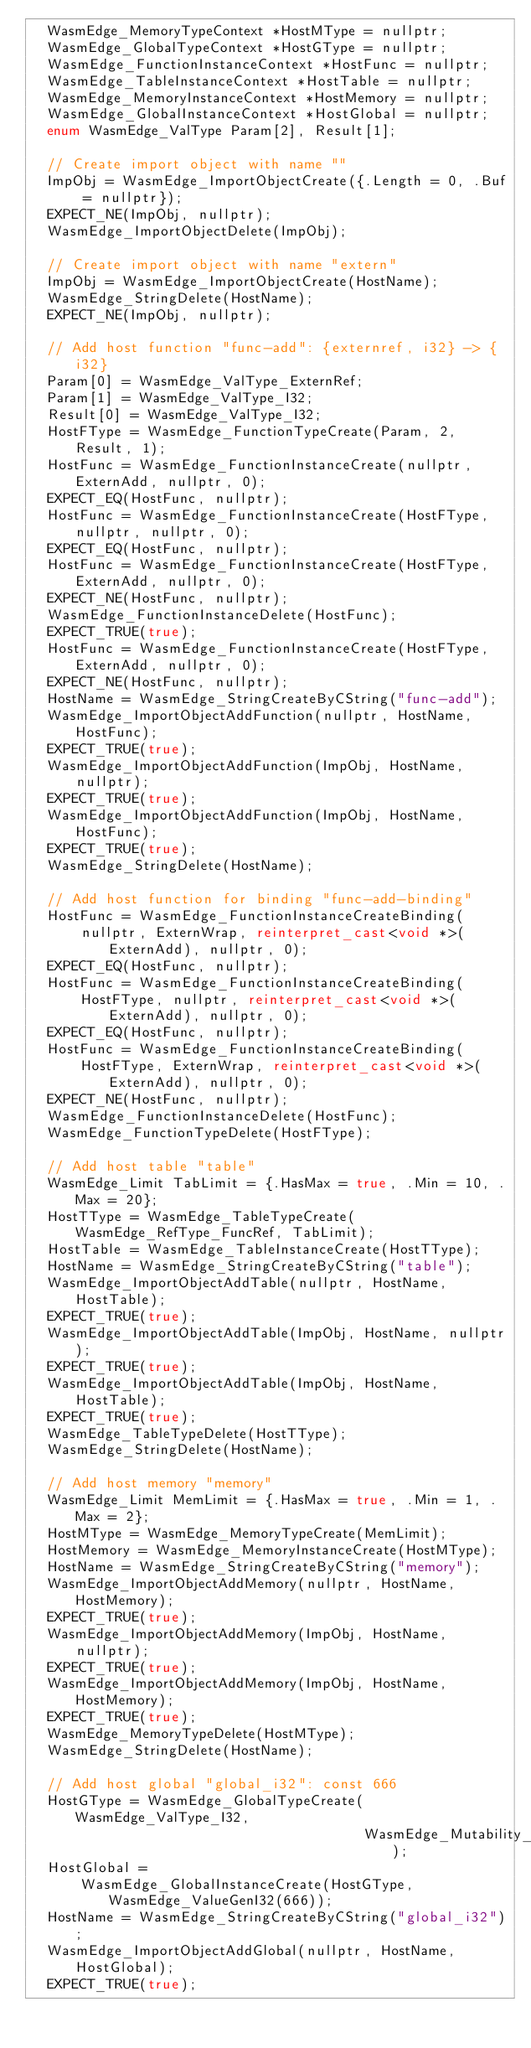Convert code to text. <code><loc_0><loc_0><loc_500><loc_500><_C++_>  WasmEdge_MemoryTypeContext *HostMType = nullptr;
  WasmEdge_GlobalTypeContext *HostGType = nullptr;
  WasmEdge_FunctionInstanceContext *HostFunc = nullptr;
  WasmEdge_TableInstanceContext *HostTable = nullptr;
  WasmEdge_MemoryInstanceContext *HostMemory = nullptr;
  WasmEdge_GlobalInstanceContext *HostGlobal = nullptr;
  enum WasmEdge_ValType Param[2], Result[1];

  // Create import object with name ""
  ImpObj = WasmEdge_ImportObjectCreate({.Length = 0, .Buf = nullptr});
  EXPECT_NE(ImpObj, nullptr);
  WasmEdge_ImportObjectDelete(ImpObj);

  // Create import object with name "extern"
  ImpObj = WasmEdge_ImportObjectCreate(HostName);
  WasmEdge_StringDelete(HostName);
  EXPECT_NE(ImpObj, nullptr);

  // Add host function "func-add": {externref, i32} -> {i32}
  Param[0] = WasmEdge_ValType_ExternRef;
  Param[1] = WasmEdge_ValType_I32;
  Result[0] = WasmEdge_ValType_I32;
  HostFType = WasmEdge_FunctionTypeCreate(Param, 2, Result, 1);
  HostFunc = WasmEdge_FunctionInstanceCreate(nullptr, ExternAdd, nullptr, 0);
  EXPECT_EQ(HostFunc, nullptr);
  HostFunc = WasmEdge_FunctionInstanceCreate(HostFType, nullptr, nullptr, 0);
  EXPECT_EQ(HostFunc, nullptr);
  HostFunc = WasmEdge_FunctionInstanceCreate(HostFType, ExternAdd, nullptr, 0);
  EXPECT_NE(HostFunc, nullptr);
  WasmEdge_FunctionInstanceDelete(HostFunc);
  EXPECT_TRUE(true);
  HostFunc = WasmEdge_FunctionInstanceCreate(HostFType, ExternAdd, nullptr, 0);
  EXPECT_NE(HostFunc, nullptr);
  HostName = WasmEdge_StringCreateByCString("func-add");
  WasmEdge_ImportObjectAddFunction(nullptr, HostName, HostFunc);
  EXPECT_TRUE(true);
  WasmEdge_ImportObjectAddFunction(ImpObj, HostName, nullptr);
  EXPECT_TRUE(true);
  WasmEdge_ImportObjectAddFunction(ImpObj, HostName, HostFunc);
  EXPECT_TRUE(true);
  WasmEdge_StringDelete(HostName);

  // Add host function for binding "func-add-binding"
  HostFunc = WasmEdge_FunctionInstanceCreateBinding(
      nullptr, ExternWrap, reinterpret_cast<void *>(ExternAdd), nullptr, 0);
  EXPECT_EQ(HostFunc, nullptr);
  HostFunc = WasmEdge_FunctionInstanceCreateBinding(
      HostFType, nullptr, reinterpret_cast<void *>(ExternAdd), nullptr, 0);
  EXPECT_EQ(HostFunc, nullptr);
  HostFunc = WasmEdge_FunctionInstanceCreateBinding(
      HostFType, ExternWrap, reinterpret_cast<void *>(ExternAdd), nullptr, 0);
  EXPECT_NE(HostFunc, nullptr);
  WasmEdge_FunctionInstanceDelete(HostFunc);
  WasmEdge_FunctionTypeDelete(HostFType);

  // Add host table "table"
  WasmEdge_Limit TabLimit = {.HasMax = true, .Min = 10, .Max = 20};
  HostTType = WasmEdge_TableTypeCreate(WasmEdge_RefType_FuncRef, TabLimit);
  HostTable = WasmEdge_TableInstanceCreate(HostTType);
  HostName = WasmEdge_StringCreateByCString("table");
  WasmEdge_ImportObjectAddTable(nullptr, HostName, HostTable);
  EXPECT_TRUE(true);
  WasmEdge_ImportObjectAddTable(ImpObj, HostName, nullptr);
  EXPECT_TRUE(true);
  WasmEdge_ImportObjectAddTable(ImpObj, HostName, HostTable);
  EXPECT_TRUE(true);
  WasmEdge_TableTypeDelete(HostTType);
  WasmEdge_StringDelete(HostName);

  // Add host memory "memory"
  WasmEdge_Limit MemLimit = {.HasMax = true, .Min = 1, .Max = 2};
  HostMType = WasmEdge_MemoryTypeCreate(MemLimit);
  HostMemory = WasmEdge_MemoryInstanceCreate(HostMType);
  HostName = WasmEdge_StringCreateByCString("memory");
  WasmEdge_ImportObjectAddMemory(nullptr, HostName, HostMemory);
  EXPECT_TRUE(true);
  WasmEdge_ImportObjectAddMemory(ImpObj, HostName, nullptr);
  EXPECT_TRUE(true);
  WasmEdge_ImportObjectAddMemory(ImpObj, HostName, HostMemory);
  EXPECT_TRUE(true);
  WasmEdge_MemoryTypeDelete(HostMType);
  WasmEdge_StringDelete(HostName);

  // Add host global "global_i32": const 666
  HostGType = WasmEdge_GlobalTypeCreate(WasmEdge_ValType_I32,
                                        WasmEdge_Mutability_Const);
  HostGlobal =
      WasmEdge_GlobalInstanceCreate(HostGType, WasmEdge_ValueGenI32(666));
  HostName = WasmEdge_StringCreateByCString("global_i32");
  WasmEdge_ImportObjectAddGlobal(nullptr, HostName, HostGlobal);
  EXPECT_TRUE(true);</code> 